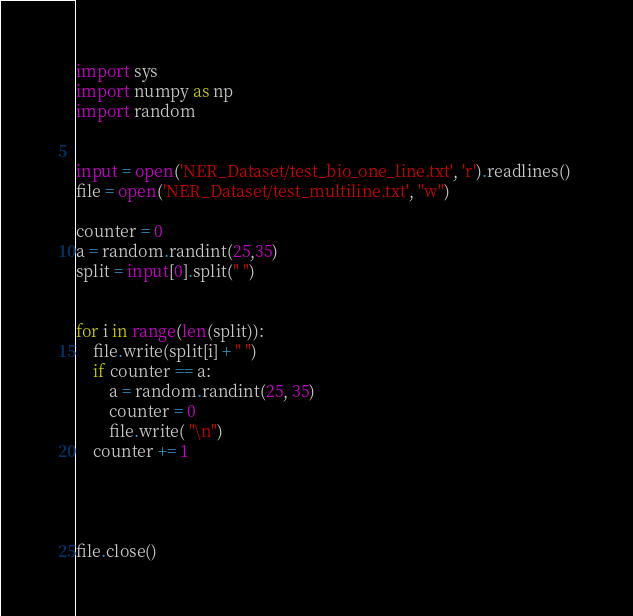Convert code to text. <code><loc_0><loc_0><loc_500><loc_500><_Python_>import sys 
import numpy as np 
import random


input = open('NER_Dataset/test_bio_one_line.txt', 'r').readlines() 
file = open('NER_Dataset/test_multiline.txt', "w")  

counter = 0
a = random.randint(25,35) 
split = input[0].split(" ")


for i in range(len(split)):
    file.write(split[i] + " ")
    if counter == a:
        a = random.randint(25, 35)
        counter = 0
        file.write( "\n")
    counter += 1




file.close()</code> 